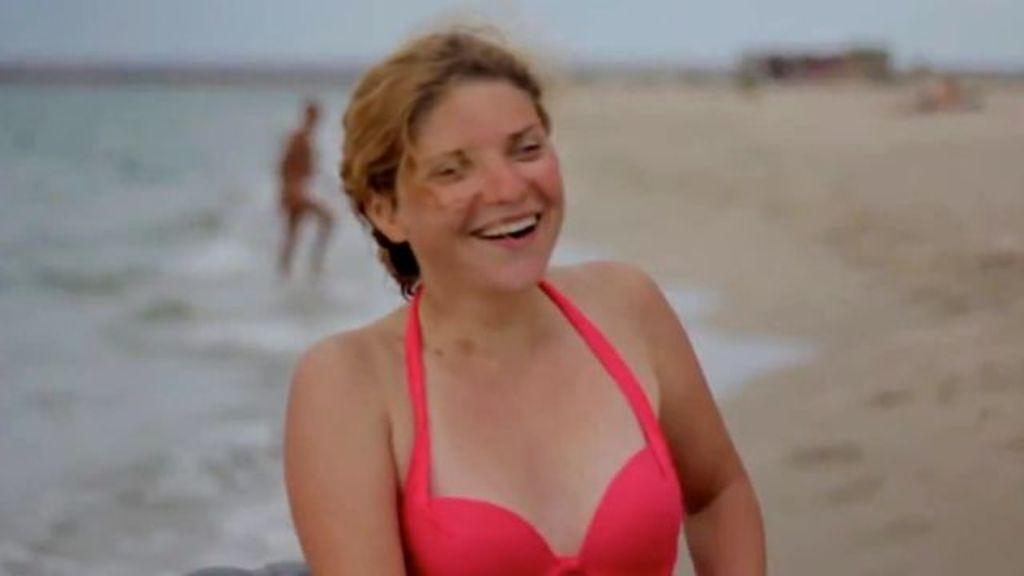Who is the main subject in the image? There is a woman in the center of the image. What is the woman doing in the image? The woman is smiling. Where is the other person located in the image? The other person is on the side of a beach. What type of terrain is visible on the right side of the image? Sand is visible on the right side of the image. What is the purpose of the vessel in the image? There is no vessel present in the image. What does the son of the woman in the image look like? There is no son of the woman mentioned or visible in the image. 